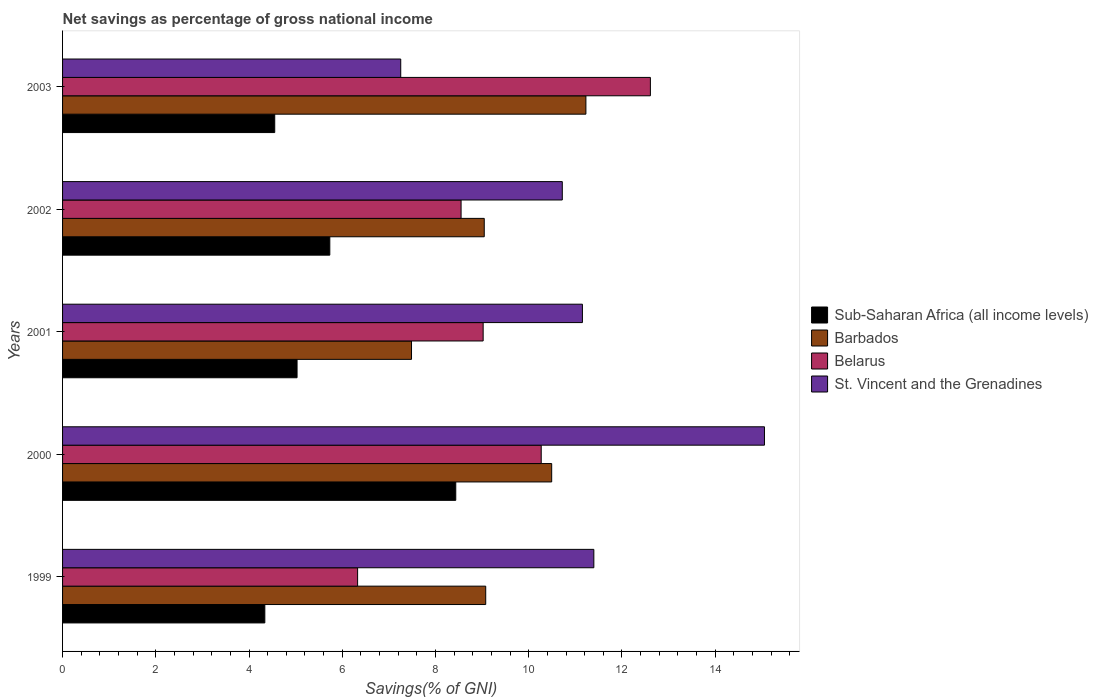How many different coloured bars are there?
Offer a very short reply. 4. Are the number of bars on each tick of the Y-axis equal?
Ensure brevity in your answer.  Yes. How many bars are there on the 1st tick from the top?
Your answer should be very brief. 4. What is the total savings in Belarus in 1999?
Your response must be concise. 6.33. Across all years, what is the maximum total savings in St. Vincent and the Grenadines?
Keep it short and to the point. 15.06. Across all years, what is the minimum total savings in Belarus?
Offer a terse response. 6.33. In which year was the total savings in Barbados maximum?
Your answer should be compact. 2003. What is the total total savings in Sub-Saharan Africa (all income levels) in the graph?
Offer a terse response. 28.09. What is the difference between the total savings in St. Vincent and the Grenadines in 1999 and that in 2001?
Offer a terse response. 0.25. What is the difference between the total savings in St. Vincent and the Grenadines in 2000 and the total savings in Barbados in 2001?
Provide a succinct answer. 7.57. What is the average total savings in Sub-Saharan Africa (all income levels) per year?
Offer a very short reply. 5.62. In the year 2003, what is the difference between the total savings in St. Vincent and the Grenadines and total savings in Barbados?
Provide a short and direct response. -3.97. In how many years, is the total savings in Sub-Saharan Africa (all income levels) greater than 14.4 %?
Provide a short and direct response. 0. What is the ratio of the total savings in St. Vincent and the Grenadines in 1999 to that in 2002?
Make the answer very short. 1.06. Is the total savings in Barbados in 2000 less than that in 2003?
Offer a terse response. Yes. What is the difference between the highest and the second highest total savings in St. Vincent and the Grenadines?
Keep it short and to the point. 3.66. What is the difference between the highest and the lowest total savings in Belarus?
Make the answer very short. 6.28. In how many years, is the total savings in Belarus greater than the average total savings in Belarus taken over all years?
Your answer should be very brief. 2. Is the sum of the total savings in Belarus in 2000 and 2002 greater than the maximum total savings in Sub-Saharan Africa (all income levels) across all years?
Give a very brief answer. Yes. Is it the case that in every year, the sum of the total savings in Barbados and total savings in Belarus is greater than the sum of total savings in Sub-Saharan Africa (all income levels) and total savings in St. Vincent and the Grenadines?
Make the answer very short. No. What does the 1st bar from the top in 2002 represents?
Offer a terse response. St. Vincent and the Grenadines. What does the 4th bar from the bottom in 2002 represents?
Ensure brevity in your answer.  St. Vincent and the Grenadines. Is it the case that in every year, the sum of the total savings in Belarus and total savings in St. Vincent and the Grenadines is greater than the total savings in Barbados?
Make the answer very short. Yes. What is the difference between two consecutive major ticks on the X-axis?
Give a very brief answer. 2. Does the graph contain any zero values?
Keep it short and to the point. No. Does the graph contain grids?
Provide a succinct answer. No. How many legend labels are there?
Ensure brevity in your answer.  4. What is the title of the graph?
Ensure brevity in your answer.  Net savings as percentage of gross national income. What is the label or title of the X-axis?
Your answer should be very brief. Savings(% of GNI). What is the label or title of the Y-axis?
Give a very brief answer. Years. What is the Savings(% of GNI) in Sub-Saharan Africa (all income levels) in 1999?
Your answer should be very brief. 4.34. What is the Savings(% of GNI) in Barbados in 1999?
Give a very brief answer. 9.08. What is the Savings(% of GNI) in Belarus in 1999?
Offer a terse response. 6.33. What is the Savings(% of GNI) of St. Vincent and the Grenadines in 1999?
Give a very brief answer. 11.4. What is the Savings(% of GNI) of Sub-Saharan Africa (all income levels) in 2000?
Offer a terse response. 8.43. What is the Savings(% of GNI) in Barbados in 2000?
Offer a terse response. 10.49. What is the Savings(% of GNI) in Belarus in 2000?
Keep it short and to the point. 10.27. What is the Savings(% of GNI) in St. Vincent and the Grenadines in 2000?
Offer a terse response. 15.06. What is the Savings(% of GNI) in Sub-Saharan Africa (all income levels) in 2001?
Provide a succinct answer. 5.03. What is the Savings(% of GNI) in Barbados in 2001?
Your response must be concise. 7.49. What is the Savings(% of GNI) in Belarus in 2001?
Offer a very short reply. 9.02. What is the Savings(% of GNI) of St. Vincent and the Grenadines in 2001?
Your response must be concise. 11.15. What is the Savings(% of GNI) of Sub-Saharan Africa (all income levels) in 2002?
Provide a succinct answer. 5.73. What is the Savings(% of GNI) in Barbados in 2002?
Provide a short and direct response. 9.05. What is the Savings(% of GNI) of Belarus in 2002?
Keep it short and to the point. 8.55. What is the Savings(% of GNI) of St. Vincent and the Grenadines in 2002?
Your response must be concise. 10.72. What is the Savings(% of GNI) of Sub-Saharan Africa (all income levels) in 2003?
Your answer should be very brief. 4.55. What is the Savings(% of GNI) in Barbados in 2003?
Give a very brief answer. 11.23. What is the Savings(% of GNI) in Belarus in 2003?
Provide a short and direct response. 12.61. What is the Savings(% of GNI) of St. Vincent and the Grenadines in 2003?
Your answer should be compact. 7.25. Across all years, what is the maximum Savings(% of GNI) in Sub-Saharan Africa (all income levels)?
Your answer should be compact. 8.43. Across all years, what is the maximum Savings(% of GNI) in Barbados?
Make the answer very short. 11.23. Across all years, what is the maximum Savings(% of GNI) in Belarus?
Keep it short and to the point. 12.61. Across all years, what is the maximum Savings(% of GNI) in St. Vincent and the Grenadines?
Keep it short and to the point. 15.06. Across all years, what is the minimum Savings(% of GNI) of Sub-Saharan Africa (all income levels)?
Your answer should be compact. 4.34. Across all years, what is the minimum Savings(% of GNI) in Barbados?
Your answer should be compact. 7.49. Across all years, what is the minimum Savings(% of GNI) of Belarus?
Provide a succinct answer. 6.33. Across all years, what is the minimum Savings(% of GNI) in St. Vincent and the Grenadines?
Your answer should be compact. 7.25. What is the total Savings(% of GNI) of Sub-Saharan Africa (all income levels) in the graph?
Your response must be concise. 28.09. What is the total Savings(% of GNI) in Barbados in the graph?
Give a very brief answer. 47.33. What is the total Savings(% of GNI) in Belarus in the graph?
Make the answer very short. 46.78. What is the total Savings(% of GNI) in St. Vincent and the Grenadines in the graph?
Provide a succinct answer. 55.58. What is the difference between the Savings(% of GNI) of Sub-Saharan Africa (all income levels) in 1999 and that in 2000?
Provide a succinct answer. -4.1. What is the difference between the Savings(% of GNI) of Barbados in 1999 and that in 2000?
Offer a terse response. -1.42. What is the difference between the Savings(% of GNI) of Belarus in 1999 and that in 2000?
Your answer should be very brief. -3.94. What is the difference between the Savings(% of GNI) of St. Vincent and the Grenadines in 1999 and that in 2000?
Keep it short and to the point. -3.66. What is the difference between the Savings(% of GNI) in Sub-Saharan Africa (all income levels) in 1999 and that in 2001?
Give a very brief answer. -0.69. What is the difference between the Savings(% of GNI) in Barbados in 1999 and that in 2001?
Offer a terse response. 1.59. What is the difference between the Savings(% of GNI) in Belarus in 1999 and that in 2001?
Your answer should be compact. -2.69. What is the difference between the Savings(% of GNI) of St. Vincent and the Grenadines in 1999 and that in 2001?
Offer a very short reply. 0.25. What is the difference between the Savings(% of GNI) in Sub-Saharan Africa (all income levels) in 1999 and that in 2002?
Ensure brevity in your answer.  -1.39. What is the difference between the Savings(% of GNI) of Barbados in 1999 and that in 2002?
Your response must be concise. 0.03. What is the difference between the Savings(% of GNI) in Belarus in 1999 and that in 2002?
Your answer should be compact. -2.22. What is the difference between the Savings(% of GNI) of St. Vincent and the Grenadines in 1999 and that in 2002?
Offer a terse response. 0.68. What is the difference between the Savings(% of GNI) of Sub-Saharan Africa (all income levels) in 1999 and that in 2003?
Offer a terse response. -0.21. What is the difference between the Savings(% of GNI) in Barbados in 1999 and that in 2003?
Provide a short and direct response. -2.15. What is the difference between the Savings(% of GNI) in Belarus in 1999 and that in 2003?
Provide a short and direct response. -6.28. What is the difference between the Savings(% of GNI) in St. Vincent and the Grenadines in 1999 and that in 2003?
Offer a terse response. 4.14. What is the difference between the Savings(% of GNI) of Sub-Saharan Africa (all income levels) in 2000 and that in 2001?
Your response must be concise. 3.4. What is the difference between the Savings(% of GNI) in Barbados in 2000 and that in 2001?
Offer a very short reply. 3.01. What is the difference between the Savings(% of GNI) of Belarus in 2000 and that in 2001?
Make the answer very short. 1.25. What is the difference between the Savings(% of GNI) of St. Vincent and the Grenadines in 2000 and that in 2001?
Offer a terse response. 3.91. What is the difference between the Savings(% of GNI) in Sub-Saharan Africa (all income levels) in 2000 and that in 2002?
Offer a terse response. 2.7. What is the difference between the Savings(% of GNI) in Barbados in 2000 and that in 2002?
Your answer should be compact. 1.45. What is the difference between the Savings(% of GNI) in Belarus in 2000 and that in 2002?
Provide a short and direct response. 1.72. What is the difference between the Savings(% of GNI) in St. Vincent and the Grenadines in 2000 and that in 2002?
Make the answer very short. 4.34. What is the difference between the Savings(% of GNI) of Sub-Saharan Africa (all income levels) in 2000 and that in 2003?
Offer a terse response. 3.88. What is the difference between the Savings(% of GNI) in Barbados in 2000 and that in 2003?
Provide a short and direct response. -0.73. What is the difference between the Savings(% of GNI) of Belarus in 2000 and that in 2003?
Your answer should be very brief. -2.34. What is the difference between the Savings(% of GNI) of St. Vincent and the Grenadines in 2000 and that in 2003?
Offer a very short reply. 7.8. What is the difference between the Savings(% of GNI) in Sub-Saharan Africa (all income levels) in 2001 and that in 2002?
Give a very brief answer. -0.7. What is the difference between the Savings(% of GNI) of Barbados in 2001 and that in 2002?
Your answer should be very brief. -1.56. What is the difference between the Savings(% of GNI) of Belarus in 2001 and that in 2002?
Offer a terse response. 0.47. What is the difference between the Savings(% of GNI) in St. Vincent and the Grenadines in 2001 and that in 2002?
Your answer should be very brief. 0.43. What is the difference between the Savings(% of GNI) of Sub-Saharan Africa (all income levels) in 2001 and that in 2003?
Offer a terse response. 0.48. What is the difference between the Savings(% of GNI) in Barbados in 2001 and that in 2003?
Offer a terse response. -3.74. What is the difference between the Savings(% of GNI) in Belarus in 2001 and that in 2003?
Offer a terse response. -3.59. What is the difference between the Savings(% of GNI) in St. Vincent and the Grenadines in 2001 and that in 2003?
Provide a succinct answer. 3.9. What is the difference between the Savings(% of GNI) in Sub-Saharan Africa (all income levels) in 2002 and that in 2003?
Your answer should be compact. 1.18. What is the difference between the Savings(% of GNI) in Barbados in 2002 and that in 2003?
Offer a very short reply. -2.18. What is the difference between the Savings(% of GNI) of Belarus in 2002 and that in 2003?
Keep it short and to the point. -4.06. What is the difference between the Savings(% of GNI) in St. Vincent and the Grenadines in 2002 and that in 2003?
Provide a short and direct response. 3.47. What is the difference between the Savings(% of GNI) in Sub-Saharan Africa (all income levels) in 1999 and the Savings(% of GNI) in Barbados in 2000?
Your answer should be very brief. -6.15. What is the difference between the Savings(% of GNI) of Sub-Saharan Africa (all income levels) in 1999 and the Savings(% of GNI) of Belarus in 2000?
Your answer should be compact. -5.93. What is the difference between the Savings(% of GNI) of Sub-Saharan Africa (all income levels) in 1999 and the Savings(% of GNI) of St. Vincent and the Grenadines in 2000?
Ensure brevity in your answer.  -10.72. What is the difference between the Savings(% of GNI) of Barbados in 1999 and the Savings(% of GNI) of Belarus in 2000?
Give a very brief answer. -1.19. What is the difference between the Savings(% of GNI) in Barbados in 1999 and the Savings(% of GNI) in St. Vincent and the Grenadines in 2000?
Ensure brevity in your answer.  -5.98. What is the difference between the Savings(% of GNI) of Belarus in 1999 and the Savings(% of GNI) of St. Vincent and the Grenadines in 2000?
Provide a succinct answer. -8.73. What is the difference between the Savings(% of GNI) in Sub-Saharan Africa (all income levels) in 1999 and the Savings(% of GNI) in Barbados in 2001?
Make the answer very short. -3.15. What is the difference between the Savings(% of GNI) in Sub-Saharan Africa (all income levels) in 1999 and the Savings(% of GNI) in Belarus in 2001?
Your response must be concise. -4.68. What is the difference between the Savings(% of GNI) in Sub-Saharan Africa (all income levels) in 1999 and the Savings(% of GNI) in St. Vincent and the Grenadines in 2001?
Your answer should be very brief. -6.81. What is the difference between the Savings(% of GNI) in Barbados in 1999 and the Savings(% of GNI) in Belarus in 2001?
Make the answer very short. 0.06. What is the difference between the Savings(% of GNI) of Barbados in 1999 and the Savings(% of GNI) of St. Vincent and the Grenadines in 2001?
Offer a terse response. -2.07. What is the difference between the Savings(% of GNI) of Belarus in 1999 and the Savings(% of GNI) of St. Vincent and the Grenadines in 2001?
Provide a short and direct response. -4.82. What is the difference between the Savings(% of GNI) of Sub-Saharan Africa (all income levels) in 1999 and the Savings(% of GNI) of Barbados in 2002?
Provide a short and direct response. -4.71. What is the difference between the Savings(% of GNI) of Sub-Saharan Africa (all income levels) in 1999 and the Savings(% of GNI) of Belarus in 2002?
Offer a very short reply. -4.21. What is the difference between the Savings(% of GNI) in Sub-Saharan Africa (all income levels) in 1999 and the Savings(% of GNI) in St. Vincent and the Grenadines in 2002?
Your answer should be compact. -6.38. What is the difference between the Savings(% of GNI) of Barbados in 1999 and the Savings(% of GNI) of Belarus in 2002?
Your answer should be very brief. 0.53. What is the difference between the Savings(% of GNI) of Barbados in 1999 and the Savings(% of GNI) of St. Vincent and the Grenadines in 2002?
Keep it short and to the point. -1.64. What is the difference between the Savings(% of GNI) of Belarus in 1999 and the Savings(% of GNI) of St. Vincent and the Grenadines in 2002?
Keep it short and to the point. -4.39. What is the difference between the Savings(% of GNI) in Sub-Saharan Africa (all income levels) in 1999 and the Savings(% of GNI) in Barbados in 2003?
Give a very brief answer. -6.89. What is the difference between the Savings(% of GNI) of Sub-Saharan Africa (all income levels) in 1999 and the Savings(% of GNI) of Belarus in 2003?
Your answer should be very brief. -8.27. What is the difference between the Savings(% of GNI) in Sub-Saharan Africa (all income levels) in 1999 and the Savings(% of GNI) in St. Vincent and the Grenadines in 2003?
Your response must be concise. -2.92. What is the difference between the Savings(% of GNI) of Barbados in 1999 and the Savings(% of GNI) of Belarus in 2003?
Your answer should be compact. -3.53. What is the difference between the Savings(% of GNI) in Barbados in 1999 and the Savings(% of GNI) in St. Vincent and the Grenadines in 2003?
Offer a terse response. 1.82. What is the difference between the Savings(% of GNI) in Belarus in 1999 and the Savings(% of GNI) in St. Vincent and the Grenadines in 2003?
Make the answer very short. -0.93. What is the difference between the Savings(% of GNI) of Sub-Saharan Africa (all income levels) in 2000 and the Savings(% of GNI) of Barbados in 2001?
Offer a terse response. 0.95. What is the difference between the Savings(% of GNI) of Sub-Saharan Africa (all income levels) in 2000 and the Savings(% of GNI) of Belarus in 2001?
Your response must be concise. -0.59. What is the difference between the Savings(% of GNI) in Sub-Saharan Africa (all income levels) in 2000 and the Savings(% of GNI) in St. Vincent and the Grenadines in 2001?
Provide a short and direct response. -2.72. What is the difference between the Savings(% of GNI) in Barbados in 2000 and the Savings(% of GNI) in Belarus in 2001?
Provide a succinct answer. 1.47. What is the difference between the Savings(% of GNI) in Barbados in 2000 and the Savings(% of GNI) in St. Vincent and the Grenadines in 2001?
Offer a terse response. -0.66. What is the difference between the Savings(% of GNI) of Belarus in 2000 and the Savings(% of GNI) of St. Vincent and the Grenadines in 2001?
Ensure brevity in your answer.  -0.88. What is the difference between the Savings(% of GNI) of Sub-Saharan Africa (all income levels) in 2000 and the Savings(% of GNI) of Barbados in 2002?
Your response must be concise. -0.61. What is the difference between the Savings(% of GNI) in Sub-Saharan Africa (all income levels) in 2000 and the Savings(% of GNI) in Belarus in 2002?
Your answer should be very brief. -0.11. What is the difference between the Savings(% of GNI) in Sub-Saharan Africa (all income levels) in 2000 and the Savings(% of GNI) in St. Vincent and the Grenadines in 2002?
Offer a terse response. -2.29. What is the difference between the Savings(% of GNI) of Barbados in 2000 and the Savings(% of GNI) of Belarus in 2002?
Provide a succinct answer. 1.94. What is the difference between the Savings(% of GNI) of Barbados in 2000 and the Savings(% of GNI) of St. Vincent and the Grenadines in 2002?
Provide a short and direct response. -0.23. What is the difference between the Savings(% of GNI) in Belarus in 2000 and the Savings(% of GNI) in St. Vincent and the Grenadines in 2002?
Provide a succinct answer. -0.45. What is the difference between the Savings(% of GNI) of Sub-Saharan Africa (all income levels) in 2000 and the Savings(% of GNI) of Barbados in 2003?
Provide a succinct answer. -2.79. What is the difference between the Savings(% of GNI) in Sub-Saharan Africa (all income levels) in 2000 and the Savings(% of GNI) in Belarus in 2003?
Provide a succinct answer. -4.18. What is the difference between the Savings(% of GNI) of Sub-Saharan Africa (all income levels) in 2000 and the Savings(% of GNI) of St. Vincent and the Grenadines in 2003?
Provide a short and direct response. 1.18. What is the difference between the Savings(% of GNI) in Barbados in 2000 and the Savings(% of GNI) in Belarus in 2003?
Ensure brevity in your answer.  -2.12. What is the difference between the Savings(% of GNI) in Barbados in 2000 and the Savings(% of GNI) in St. Vincent and the Grenadines in 2003?
Give a very brief answer. 3.24. What is the difference between the Savings(% of GNI) in Belarus in 2000 and the Savings(% of GNI) in St. Vincent and the Grenadines in 2003?
Your answer should be very brief. 3.01. What is the difference between the Savings(% of GNI) of Sub-Saharan Africa (all income levels) in 2001 and the Savings(% of GNI) of Barbados in 2002?
Make the answer very short. -4.02. What is the difference between the Savings(% of GNI) of Sub-Saharan Africa (all income levels) in 2001 and the Savings(% of GNI) of Belarus in 2002?
Your response must be concise. -3.52. What is the difference between the Savings(% of GNI) in Sub-Saharan Africa (all income levels) in 2001 and the Savings(% of GNI) in St. Vincent and the Grenadines in 2002?
Provide a short and direct response. -5.69. What is the difference between the Savings(% of GNI) of Barbados in 2001 and the Savings(% of GNI) of Belarus in 2002?
Your answer should be compact. -1.06. What is the difference between the Savings(% of GNI) in Barbados in 2001 and the Savings(% of GNI) in St. Vincent and the Grenadines in 2002?
Offer a terse response. -3.23. What is the difference between the Savings(% of GNI) in Belarus in 2001 and the Savings(% of GNI) in St. Vincent and the Grenadines in 2002?
Provide a short and direct response. -1.7. What is the difference between the Savings(% of GNI) in Sub-Saharan Africa (all income levels) in 2001 and the Savings(% of GNI) in Barbados in 2003?
Provide a succinct answer. -6.2. What is the difference between the Savings(% of GNI) of Sub-Saharan Africa (all income levels) in 2001 and the Savings(% of GNI) of Belarus in 2003?
Offer a very short reply. -7.58. What is the difference between the Savings(% of GNI) of Sub-Saharan Africa (all income levels) in 2001 and the Savings(% of GNI) of St. Vincent and the Grenadines in 2003?
Make the answer very short. -2.22. What is the difference between the Savings(% of GNI) in Barbados in 2001 and the Savings(% of GNI) in Belarus in 2003?
Make the answer very short. -5.12. What is the difference between the Savings(% of GNI) of Barbados in 2001 and the Savings(% of GNI) of St. Vincent and the Grenadines in 2003?
Your answer should be compact. 0.23. What is the difference between the Savings(% of GNI) in Belarus in 2001 and the Savings(% of GNI) in St. Vincent and the Grenadines in 2003?
Your answer should be very brief. 1.77. What is the difference between the Savings(% of GNI) of Sub-Saharan Africa (all income levels) in 2002 and the Savings(% of GNI) of Barbados in 2003?
Your answer should be very brief. -5.49. What is the difference between the Savings(% of GNI) in Sub-Saharan Africa (all income levels) in 2002 and the Savings(% of GNI) in Belarus in 2003?
Provide a succinct answer. -6.88. What is the difference between the Savings(% of GNI) of Sub-Saharan Africa (all income levels) in 2002 and the Savings(% of GNI) of St. Vincent and the Grenadines in 2003?
Give a very brief answer. -1.52. What is the difference between the Savings(% of GNI) in Barbados in 2002 and the Savings(% of GNI) in Belarus in 2003?
Make the answer very short. -3.56. What is the difference between the Savings(% of GNI) in Barbados in 2002 and the Savings(% of GNI) in St. Vincent and the Grenadines in 2003?
Keep it short and to the point. 1.79. What is the difference between the Savings(% of GNI) of Belarus in 2002 and the Savings(% of GNI) of St. Vincent and the Grenadines in 2003?
Provide a succinct answer. 1.29. What is the average Savings(% of GNI) of Sub-Saharan Africa (all income levels) per year?
Your answer should be compact. 5.62. What is the average Savings(% of GNI) of Barbados per year?
Your answer should be compact. 9.47. What is the average Savings(% of GNI) in Belarus per year?
Make the answer very short. 9.36. What is the average Savings(% of GNI) of St. Vincent and the Grenadines per year?
Make the answer very short. 11.12. In the year 1999, what is the difference between the Savings(% of GNI) of Sub-Saharan Africa (all income levels) and Savings(% of GNI) of Barbados?
Provide a succinct answer. -4.74. In the year 1999, what is the difference between the Savings(% of GNI) of Sub-Saharan Africa (all income levels) and Savings(% of GNI) of Belarus?
Your answer should be compact. -1.99. In the year 1999, what is the difference between the Savings(% of GNI) of Sub-Saharan Africa (all income levels) and Savings(% of GNI) of St. Vincent and the Grenadines?
Make the answer very short. -7.06. In the year 1999, what is the difference between the Savings(% of GNI) in Barbados and Savings(% of GNI) in Belarus?
Your answer should be compact. 2.75. In the year 1999, what is the difference between the Savings(% of GNI) of Barbados and Savings(% of GNI) of St. Vincent and the Grenadines?
Your response must be concise. -2.32. In the year 1999, what is the difference between the Savings(% of GNI) of Belarus and Savings(% of GNI) of St. Vincent and the Grenadines?
Make the answer very short. -5.07. In the year 2000, what is the difference between the Savings(% of GNI) in Sub-Saharan Africa (all income levels) and Savings(% of GNI) in Barbados?
Ensure brevity in your answer.  -2.06. In the year 2000, what is the difference between the Savings(% of GNI) in Sub-Saharan Africa (all income levels) and Savings(% of GNI) in Belarus?
Provide a short and direct response. -1.83. In the year 2000, what is the difference between the Savings(% of GNI) in Sub-Saharan Africa (all income levels) and Savings(% of GNI) in St. Vincent and the Grenadines?
Make the answer very short. -6.62. In the year 2000, what is the difference between the Savings(% of GNI) of Barbados and Savings(% of GNI) of Belarus?
Offer a terse response. 0.22. In the year 2000, what is the difference between the Savings(% of GNI) of Barbados and Savings(% of GNI) of St. Vincent and the Grenadines?
Make the answer very short. -4.56. In the year 2000, what is the difference between the Savings(% of GNI) of Belarus and Savings(% of GNI) of St. Vincent and the Grenadines?
Keep it short and to the point. -4.79. In the year 2001, what is the difference between the Savings(% of GNI) in Sub-Saharan Africa (all income levels) and Savings(% of GNI) in Barbados?
Give a very brief answer. -2.46. In the year 2001, what is the difference between the Savings(% of GNI) in Sub-Saharan Africa (all income levels) and Savings(% of GNI) in Belarus?
Ensure brevity in your answer.  -3.99. In the year 2001, what is the difference between the Savings(% of GNI) of Sub-Saharan Africa (all income levels) and Savings(% of GNI) of St. Vincent and the Grenadines?
Make the answer very short. -6.12. In the year 2001, what is the difference between the Savings(% of GNI) in Barbados and Savings(% of GNI) in Belarus?
Give a very brief answer. -1.54. In the year 2001, what is the difference between the Savings(% of GNI) of Barbados and Savings(% of GNI) of St. Vincent and the Grenadines?
Make the answer very short. -3.67. In the year 2001, what is the difference between the Savings(% of GNI) of Belarus and Savings(% of GNI) of St. Vincent and the Grenadines?
Provide a succinct answer. -2.13. In the year 2002, what is the difference between the Savings(% of GNI) of Sub-Saharan Africa (all income levels) and Savings(% of GNI) of Barbados?
Give a very brief answer. -3.31. In the year 2002, what is the difference between the Savings(% of GNI) of Sub-Saharan Africa (all income levels) and Savings(% of GNI) of Belarus?
Provide a succinct answer. -2.82. In the year 2002, what is the difference between the Savings(% of GNI) in Sub-Saharan Africa (all income levels) and Savings(% of GNI) in St. Vincent and the Grenadines?
Your answer should be compact. -4.99. In the year 2002, what is the difference between the Savings(% of GNI) in Barbados and Savings(% of GNI) in Belarus?
Offer a very short reply. 0.5. In the year 2002, what is the difference between the Savings(% of GNI) of Barbados and Savings(% of GNI) of St. Vincent and the Grenadines?
Keep it short and to the point. -1.67. In the year 2002, what is the difference between the Savings(% of GNI) of Belarus and Savings(% of GNI) of St. Vincent and the Grenadines?
Your answer should be compact. -2.17. In the year 2003, what is the difference between the Savings(% of GNI) in Sub-Saharan Africa (all income levels) and Savings(% of GNI) in Barbados?
Your answer should be compact. -6.68. In the year 2003, what is the difference between the Savings(% of GNI) of Sub-Saharan Africa (all income levels) and Savings(% of GNI) of Belarus?
Provide a succinct answer. -8.06. In the year 2003, what is the difference between the Savings(% of GNI) of Sub-Saharan Africa (all income levels) and Savings(% of GNI) of St. Vincent and the Grenadines?
Offer a terse response. -2.7. In the year 2003, what is the difference between the Savings(% of GNI) of Barbados and Savings(% of GNI) of Belarus?
Ensure brevity in your answer.  -1.38. In the year 2003, what is the difference between the Savings(% of GNI) in Barbados and Savings(% of GNI) in St. Vincent and the Grenadines?
Provide a short and direct response. 3.97. In the year 2003, what is the difference between the Savings(% of GNI) in Belarus and Savings(% of GNI) in St. Vincent and the Grenadines?
Keep it short and to the point. 5.36. What is the ratio of the Savings(% of GNI) of Sub-Saharan Africa (all income levels) in 1999 to that in 2000?
Ensure brevity in your answer.  0.51. What is the ratio of the Savings(% of GNI) in Barbados in 1999 to that in 2000?
Your answer should be very brief. 0.87. What is the ratio of the Savings(% of GNI) in Belarus in 1999 to that in 2000?
Keep it short and to the point. 0.62. What is the ratio of the Savings(% of GNI) in St. Vincent and the Grenadines in 1999 to that in 2000?
Give a very brief answer. 0.76. What is the ratio of the Savings(% of GNI) in Sub-Saharan Africa (all income levels) in 1999 to that in 2001?
Keep it short and to the point. 0.86. What is the ratio of the Savings(% of GNI) of Barbados in 1999 to that in 2001?
Offer a terse response. 1.21. What is the ratio of the Savings(% of GNI) of Belarus in 1999 to that in 2001?
Provide a succinct answer. 0.7. What is the ratio of the Savings(% of GNI) of Sub-Saharan Africa (all income levels) in 1999 to that in 2002?
Provide a short and direct response. 0.76. What is the ratio of the Savings(% of GNI) of Belarus in 1999 to that in 2002?
Provide a succinct answer. 0.74. What is the ratio of the Savings(% of GNI) in St. Vincent and the Grenadines in 1999 to that in 2002?
Your answer should be very brief. 1.06. What is the ratio of the Savings(% of GNI) in Sub-Saharan Africa (all income levels) in 1999 to that in 2003?
Provide a succinct answer. 0.95. What is the ratio of the Savings(% of GNI) in Barbados in 1999 to that in 2003?
Provide a short and direct response. 0.81. What is the ratio of the Savings(% of GNI) in Belarus in 1999 to that in 2003?
Provide a succinct answer. 0.5. What is the ratio of the Savings(% of GNI) in St. Vincent and the Grenadines in 1999 to that in 2003?
Your response must be concise. 1.57. What is the ratio of the Savings(% of GNI) of Sub-Saharan Africa (all income levels) in 2000 to that in 2001?
Your answer should be compact. 1.68. What is the ratio of the Savings(% of GNI) in Barbados in 2000 to that in 2001?
Offer a very short reply. 1.4. What is the ratio of the Savings(% of GNI) in Belarus in 2000 to that in 2001?
Keep it short and to the point. 1.14. What is the ratio of the Savings(% of GNI) in St. Vincent and the Grenadines in 2000 to that in 2001?
Your response must be concise. 1.35. What is the ratio of the Savings(% of GNI) in Sub-Saharan Africa (all income levels) in 2000 to that in 2002?
Your answer should be very brief. 1.47. What is the ratio of the Savings(% of GNI) of Barbados in 2000 to that in 2002?
Your answer should be very brief. 1.16. What is the ratio of the Savings(% of GNI) in Belarus in 2000 to that in 2002?
Provide a succinct answer. 1.2. What is the ratio of the Savings(% of GNI) of St. Vincent and the Grenadines in 2000 to that in 2002?
Make the answer very short. 1.4. What is the ratio of the Savings(% of GNI) in Sub-Saharan Africa (all income levels) in 2000 to that in 2003?
Your answer should be compact. 1.85. What is the ratio of the Savings(% of GNI) in Barbados in 2000 to that in 2003?
Your response must be concise. 0.93. What is the ratio of the Savings(% of GNI) in Belarus in 2000 to that in 2003?
Make the answer very short. 0.81. What is the ratio of the Savings(% of GNI) in St. Vincent and the Grenadines in 2000 to that in 2003?
Provide a short and direct response. 2.08. What is the ratio of the Savings(% of GNI) in Sub-Saharan Africa (all income levels) in 2001 to that in 2002?
Give a very brief answer. 0.88. What is the ratio of the Savings(% of GNI) of Barbados in 2001 to that in 2002?
Ensure brevity in your answer.  0.83. What is the ratio of the Savings(% of GNI) of Belarus in 2001 to that in 2002?
Keep it short and to the point. 1.06. What is the ratio of the Savings(% of GNI) of St. Vincent and the Grenadines in 2001 to that in 2002?
Provide a short and direct response. 1.04. What is the ratio of the Savings(% of GNI) of Sub-Saharan Africa (all income levels) in 2001 to that in 2003?
Make the answer very short. 1.11. What is the ratio of the Savings(% of GNI) of Barbados in 2001 to that in 2003?
Make the answer very short. 0.67. What is the ratio of the Savings(% of GNI) in Belarus in 2001 to that in 2003?
Offer a very short reply. 0.72. What is the ratio of the Savings(% of GNI) of St. Vincent and the Grenadines in 2001 to that in 2003?
Your response must be concise. 1.54. What is the ratio of the Savings(% of GNI) in Sub-Saharan Africa (all income levels) in 2002 to that in 2003?
Your answer should be very brief. 1.26. What is the ratio of the Savings(% of GNI) in Barbados in 2002 to that in 2003?
Offer a very short reply. 0.81. What is the ratio of the Savings(% of GNI) of Belarus in 2002 to that in 2003?
Keep it short and to the point. 0.68. What is the ratio of the Savings(% of GNI) in St. Vincent and the Grenadines in 2002 to that in 2003?
Offer a terse response. 1.48. What is the difference between the highest and the second highest Savings(% of GNI) in Sub-Saharan Africa (all income levels)?
Your response must be concise. 2.7. What is the difference between the highest and the second highest Savings(% of GNI) of Barbados?
Provide a succinct answer. 0.73. What is the difference between the highest and the second highest Savings(% of GNI) of Belarus?
Your answer should be compact. 2.34. What is the difference between the highest and the second highest Savings(% of GNI) of St. Vincent and the Grenadines?
Provide a succinct answer. 3.66. What is the difference between the highest and the lowest Savings(% of GNI) in Sub-Saharan Africa (all income levels)?
Ensure brevity in your answer.  4.1. What is the difference between the highest and the lowest Savings(% of GNI) in Barbados?
Make the answer very short. 3.74. What is the difference between the highest and the lowest Savings(% of GNI) of Belarus?
Give a very brief answer. 6.28. What is the difference between the highest and the lowest Savings(% of GNI) in St. Vincent and the Grenadines?
Your response must be concise. 7.8. 